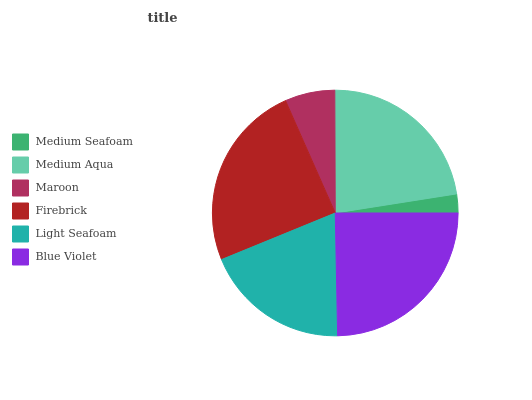Is Medium Seafoam the minimum?
Answer yes or no. Yes. Is Blue Violet the maximum?
Answer yes or no. Yes. Is Medium Aqua the minimum?
Answer yes or no. No. Is Medium Aqua the maximum?
Answer yes or no. No. Is Medium Aqua greater than Medium Seafoam?
Answer yes or no. Yes. Is Medium Seafoam less than Medium Aqua?
Answer yes or no. Yes. Is Medium Seafoam greater than Medium Aqua?
Answer yes or no. No. Is Medium Aqua less than Medium Seafoam?
Answer yes or no. No. Is Medium Aqua the high median?
Answer yes or no. Yes. Is Light Seafoam the low median?
Answer yes or no. Yes. Is Firebrick the high median?
Answer yes or no. No. Is Firebrick the low median?
Answer yes or no. No. 